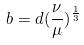Convert formula to latex. <formula><loc_0><loc_0><loc_500><loc_500>b = d ( \frac { \nu } { \mu } ) ^ { \frac { 1 } { 3 } }</formula> 